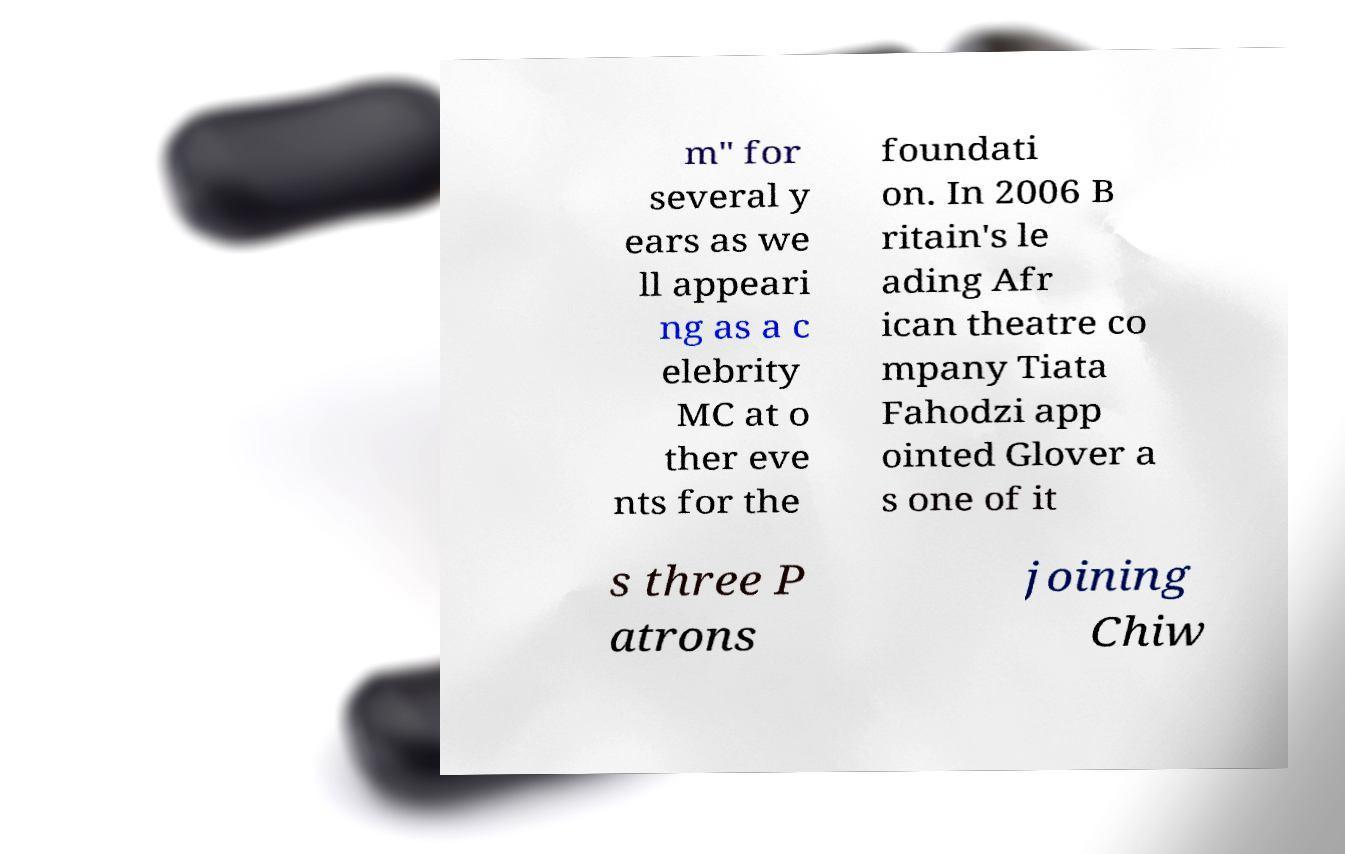There's text embedded in this image that I need extracted. Can you transcribe it verbatim? m" for several y ears as we ll appeari ng as a c elebrity MC at o ther eve nts for the foundati on. In 2006 B ritain's le ading Afr ican theatre co mpany Tiata Fahodzi app ointed Glover a s one of it s three P atrons joining Chiw 